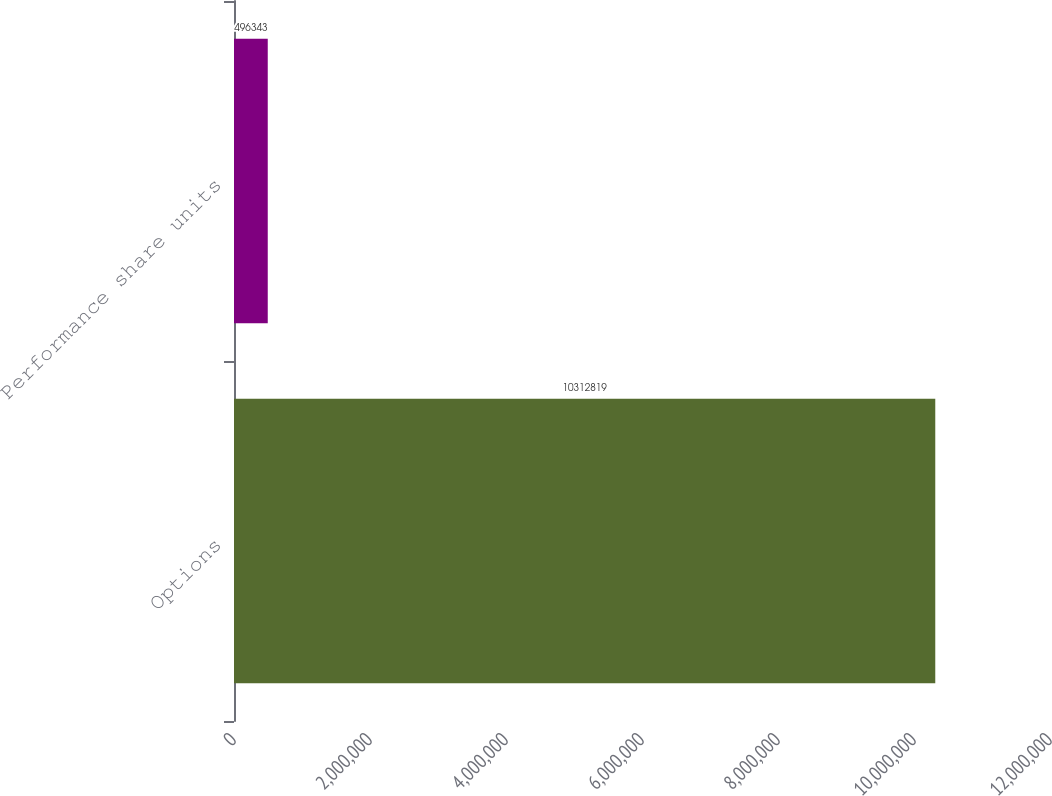<chart> <loc_0><loc_0><loc_500><loc_500><bar_chart><fcel>Options<fcel>Performance share units<nl><fcel>1.03128e+07<fcel>496343<nl></chart> 